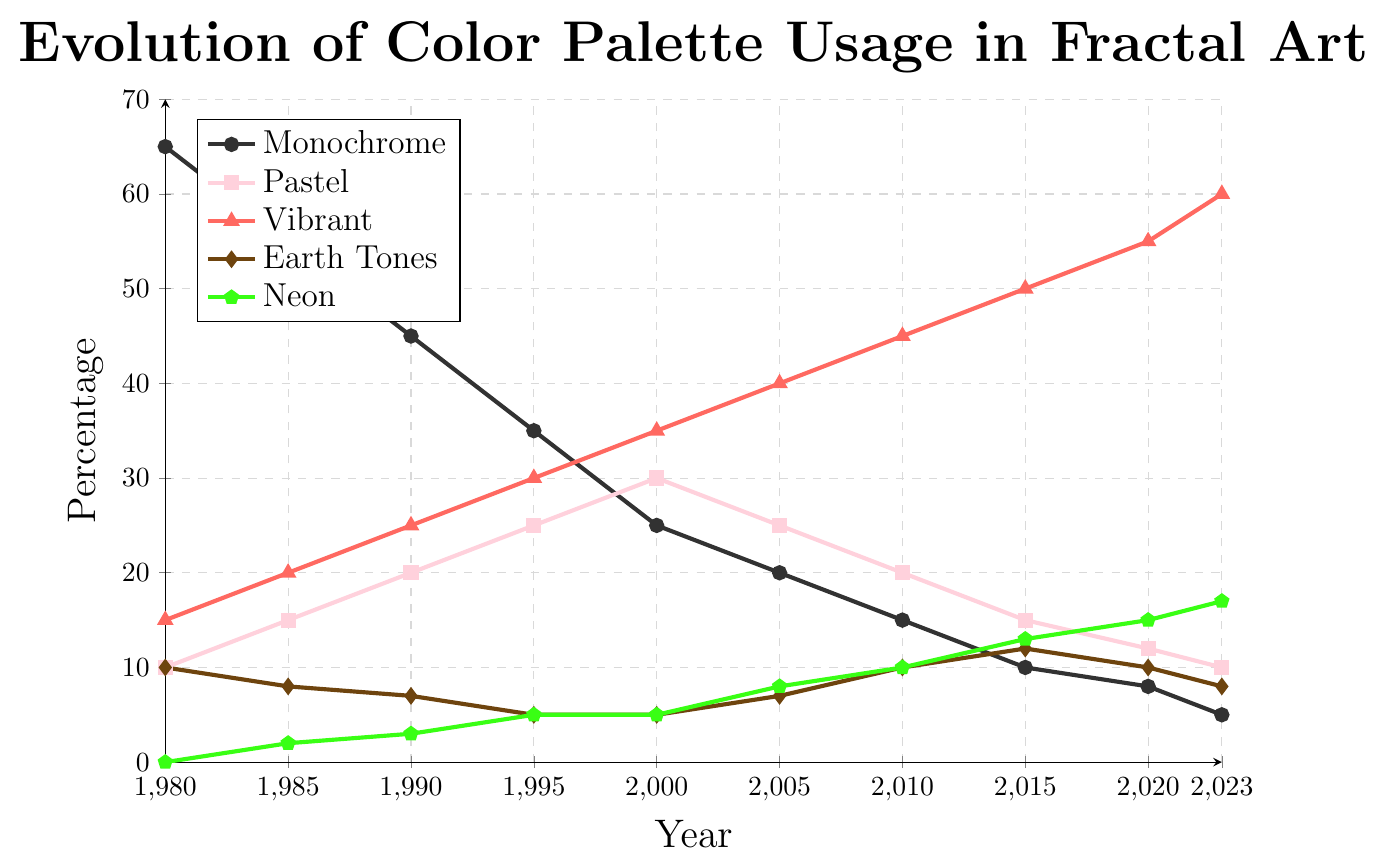What's the most used color palette in 2023? In 2023, the line representing "Vibrant" is the highest among all the color palettes on the y-axis. This indicates that vibrant colors are used the most compared to other palettes.
Answer: Vibrant How much has the usage of Monochrome decreased from 1980 to 2023? The usage of Monochrome in 1980 was 65%, and it reduced to 5% by 2023. The decrease is calculated by subtracting the usage in 2023 from the usage in 1980: 65 - 5 = 60%.
Answer: 60% Which color palette shows a steady increase over the years, reaching its peak in 2023? Observing the lines on the chart, the "Vibrant" color palette consistently increases in usage every year from 1980 to 2023, reaching the highest point in 2023 at 60%.
Answer: Vibrant What is the difference in the usage of Pastel colors between 1990 and 2005? In 1990, the usage of Pastel colors was 20%, and in 2005, it was 25%. The difference is calculated by subtracting the usage in 1990 from that in 2005: 25 - 20 = 5%.
Answer: 5% In which year did Neon colors first reach at least 10% usage, and what was the usage percentage then? Looking at the Neon color line, the first instance where the usage reaches at least 10% is in 2010, with the percentage being exactly 10%.
Answer: 2010, 10% Which two color palettes had identical usage percentages in 2000, and what was that percentage? Observing the chart in the year 2000, both Earth Tones and Neon colors had a usage percentage of 5%.
Answer: Earth Tones and Neon, 5% How did the usage of Earth Tones change from 1980 to 2023? In 1980, Earth Tones usage was 10%, and by 2023, it was 8%. The usage fluctuated slightly over the years but generally remained between 5% and 12%.
Answer: Fluctuated, slightly decreased What is the average usage of Vibrant colors from 1980 to 2023? The usage percentages of Vibrant colors from 1980 to 2023 are: 15, 20, 25, 30, 35, 40, 45, 50, 55, 60. Adding these gives 375. Dividing by the 10 data points, the average usage is 375 / 10 = 37.5%.
Answer: 37.5% Comparing 1980 and 1995, which color palette shows the least change in usage? By calculating the changes:
- Monochrome: 65% to 35% (Change: 30%)
- Pastel: 10% to 25% (Change: 15%)
- Vibrant: 15% to 30% (Change: 15%)
- Earth Tones: 10% to 5% (Change: 5%)
- Neon: 0% to 5% (Change: 5%)
Both Earth Tones and Neon show the smallest change, each with a change of 5%.
Answer: Earth Tones and Neon In 2010, what is the combined percentage of Monochrome, Pastel, and Neon colors? The usage percentages for Monochrome, Pastel, and Neon in 2010 are 15%, 20%, and 10% respectively. Adding these gives a combined usage of 15 + 20 + 10 = 45%.
Answer: 45% 